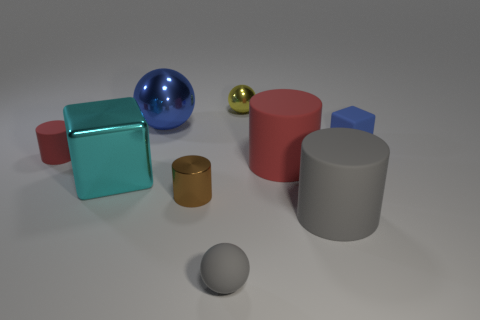Subtract all cubes. How many objects are left? 7 Add 1 gray objects. How many gray objects are left? 3 Add 1 metal things. How many metal things exist? 5 Subtract 0 yellow cubes. How many objects are left? 9 Subtract all big cyan blocks. Subtract all tiny cubes. How many objects are left? 7 